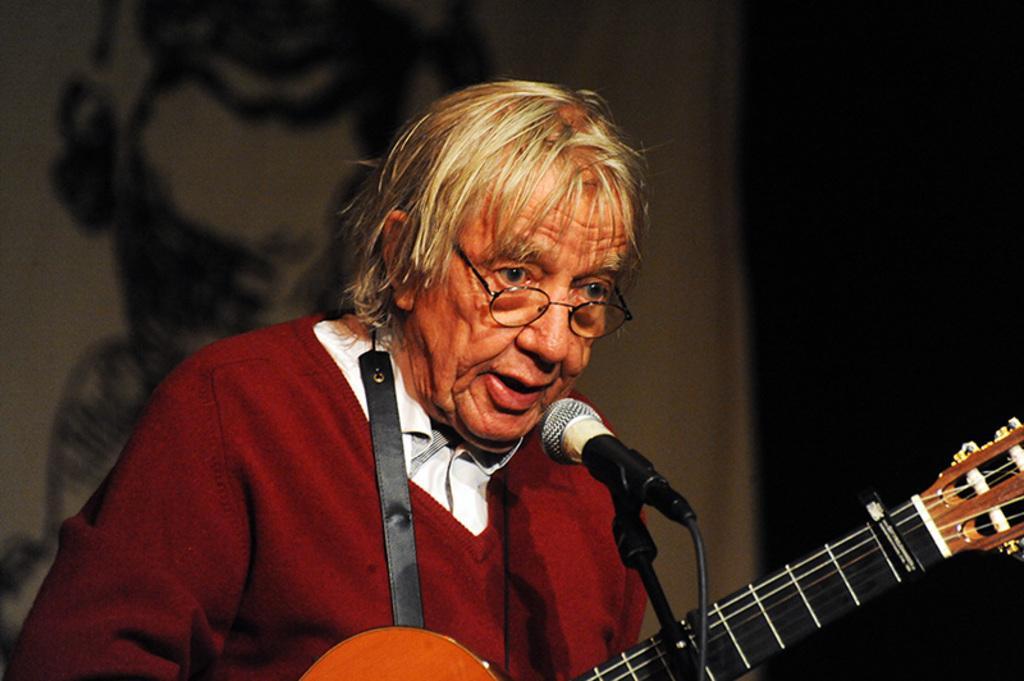How would you summarize this image in a sentence or two? In this picture we can see a woman wore sweater, spectacle holding guitar with her hand and singing on mic and in the background we can see wall. 